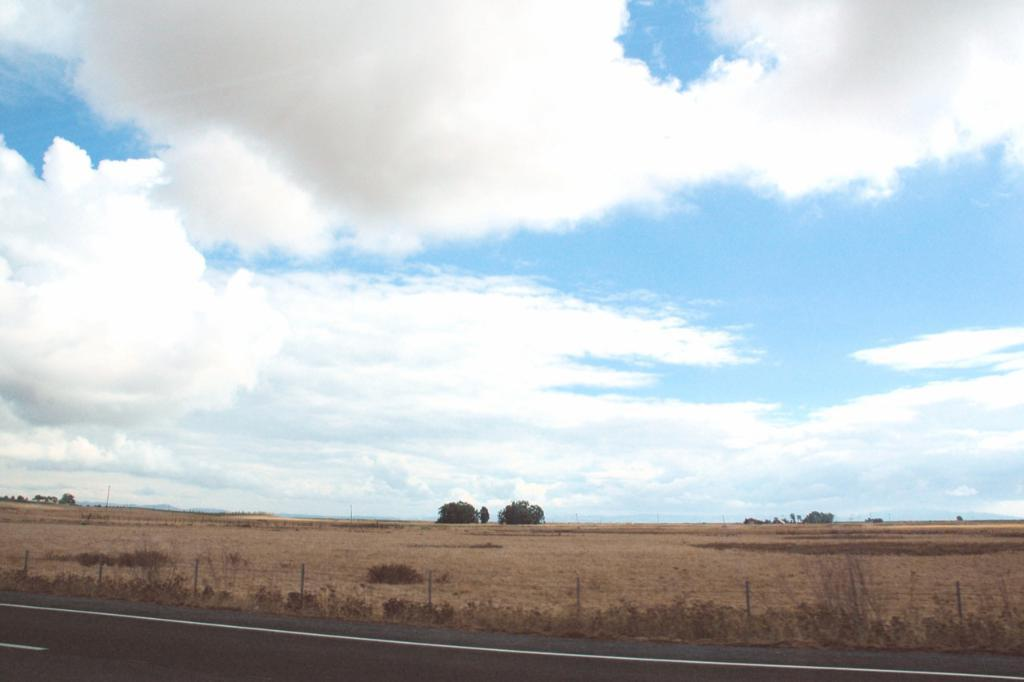What type of vegetation can be seen in the image? There are trees in the image. What structure is present in the image? There is a fence in the image. What markings can be seen on the road in the image? White lines are visible on the road. What type of ground cover is present in the image? There is grass in the image. What can be seen in the background of the image? The sky is visible in the background of the image. Can you tell me how many scissors are lying on the grass in the image? There are no scissors present in the image. What type of insect can be seen flying near the trees in the image? There are no insects visible in the image. 